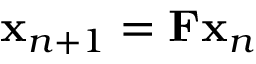<formula> <loc_0><loc_0><loc_500><loc_500>{ x } _ { n + 1 } = { F } { x } _ { n }</formula> 